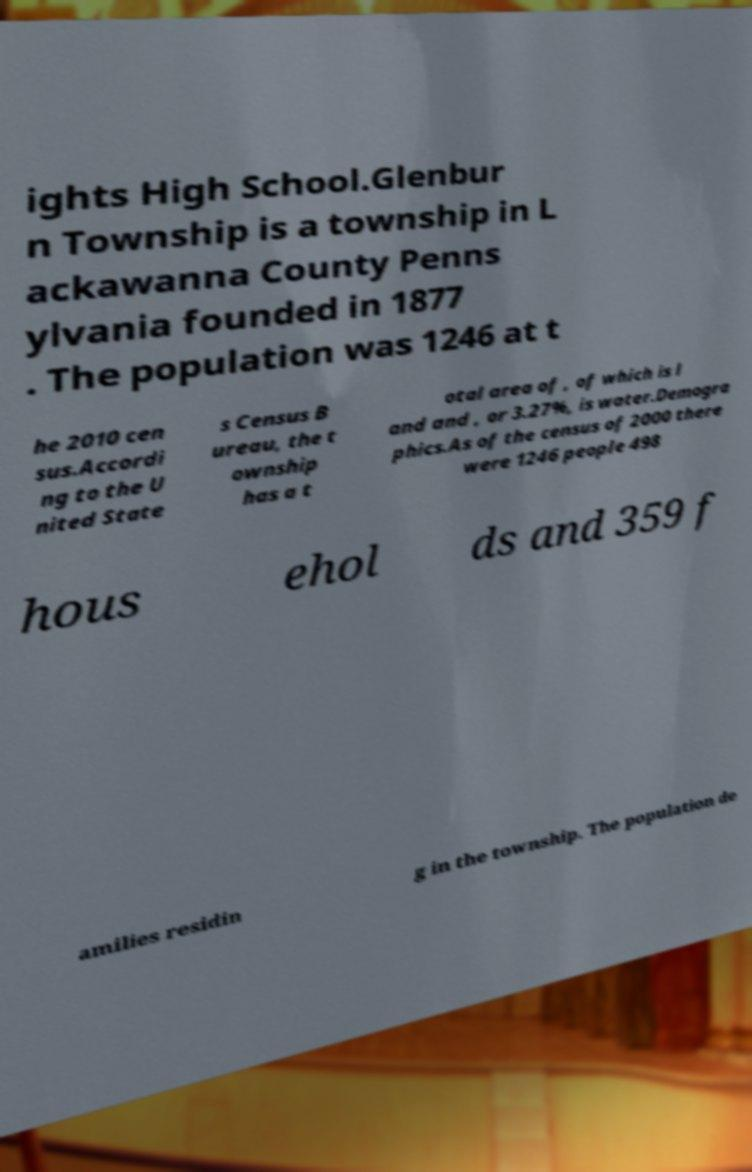Please identify and transcribe the text found in this image. ights High School.Glenbur n Township is a township in L ackawanna County Penns ylvania founded in 1877 . The population was 1246 at t he 2010 cen sus.Accordi ng to the U nited State s Census B ureau, the t ownship has a t otal area of , of which is l and and , or 3.27%, is water.Demogra phics.As of the census of 2000 there were 1246 people 498 hous ehol ds and 359 f amilies residin g in the township. The population de 